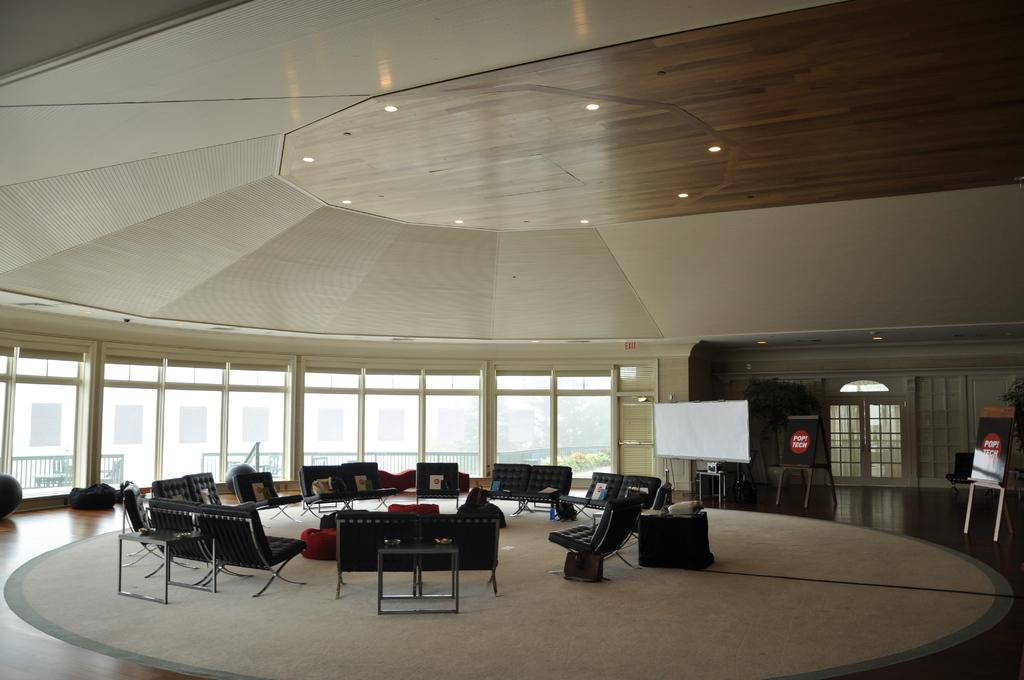What type of space is shown in the image? The image depicts an inside view of a room. What furniture can be seen in the room? There are chairs in the room. What other objects are present in the room? There are boards and lights in the room. What can be seen in the background of the image? There is a fence, a building, and plants visible in the background. What type of caption is written on the boards in the image? There is no caption written on the boards in the image; they are just plain boards. Can you tell me how many carts are parked next to the building in the background? There are no carts visible in the image; only a fence, a building, and plants can be seen in the background. 